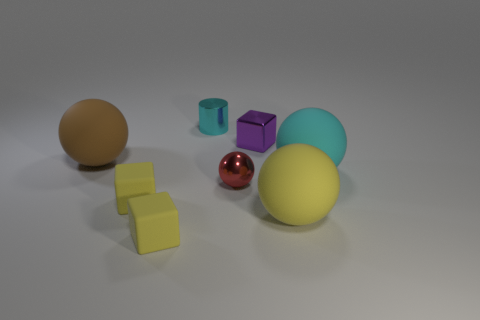Subtract 1 spheres. How many spheres are left? 3 Subtract all yellow balls. Subtract all brown cubes. How many balls are left? 3 Add 1 small rubber objects. How many objects exist? 9 Subtract all cylinders. How many objects are left? 7 Subtract 0 red cylinders. How many objects are left? 8 Subtract all small red objects. Subtract all big cyan balls. How many objects are left? 6 Add 5 tiny yellow matte objects. How many tiny yellow matte objects are left? 7 Add 8 brown cylinders. How many brown cylinders exist? 8 